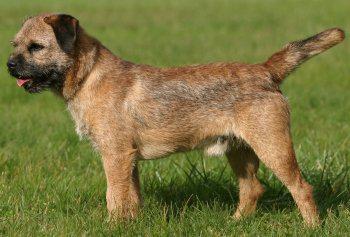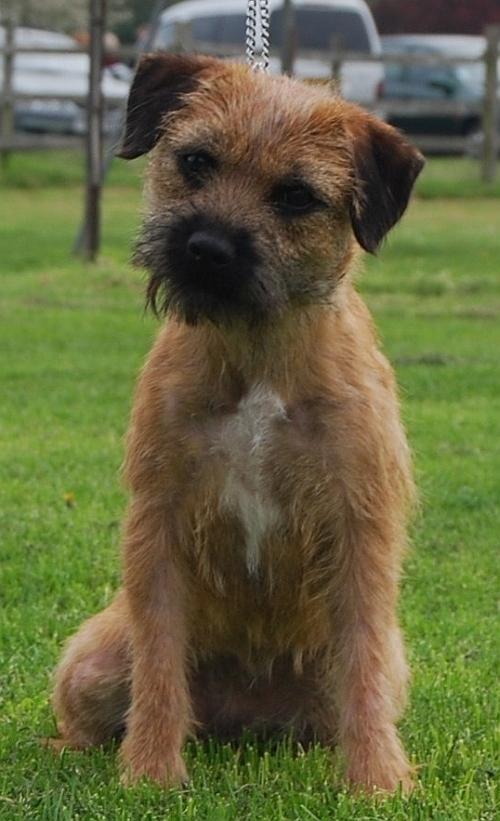The first image is the image on the left, the second image is the image on the right. Given the left and right images, does the statement "A dog is shown in profile standing on green grass in at least one image." hold true? Answer yes or no. Yes. The first image is the image on the left, the second image is the image on the right. Evaluate the accuracy of this statement regarding the images: "One dog is wearing a harness.". Is it true? Answer yes or no. No. 